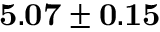<formula> <loc_0><loc_0><loc_500><loc_500>{ 5 . 0 7 \pm 0 . 1 5 }</formula> 